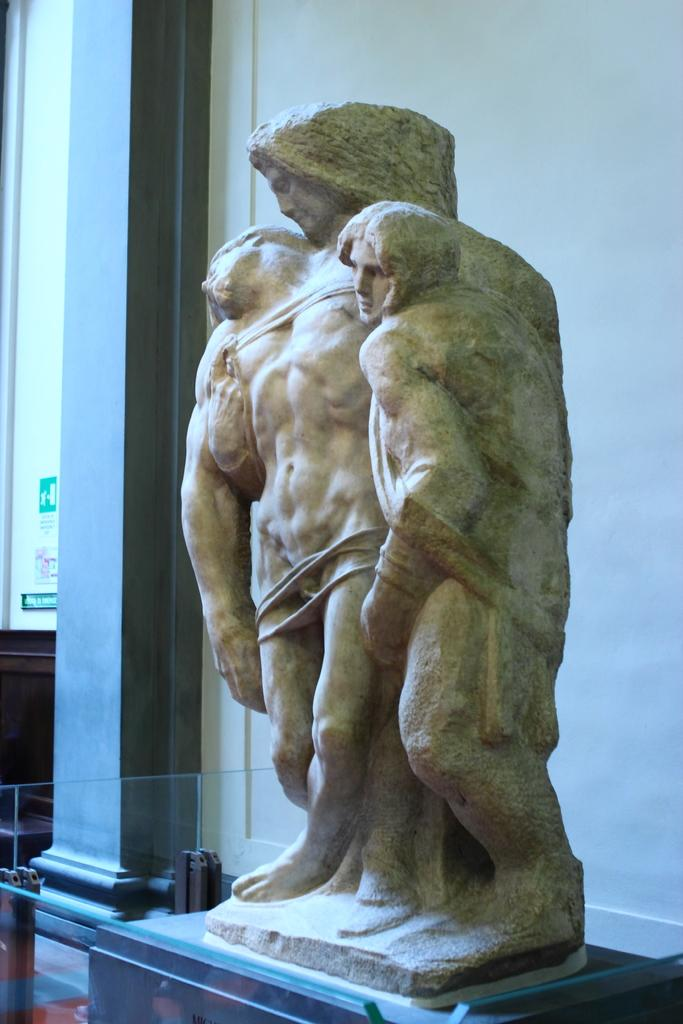What is the main subject of the image? There is a sculpture of three people in the image. What is located behind the sculpture? There is a wall behind the sculpture. What is located beside the sculpture? There is a pillar beside the sculpture. What is the name of the artist who created the sculpture in the image? The provided facts do not mention the name of the artist who created the sculpture, so it cannot be determined from the image. 